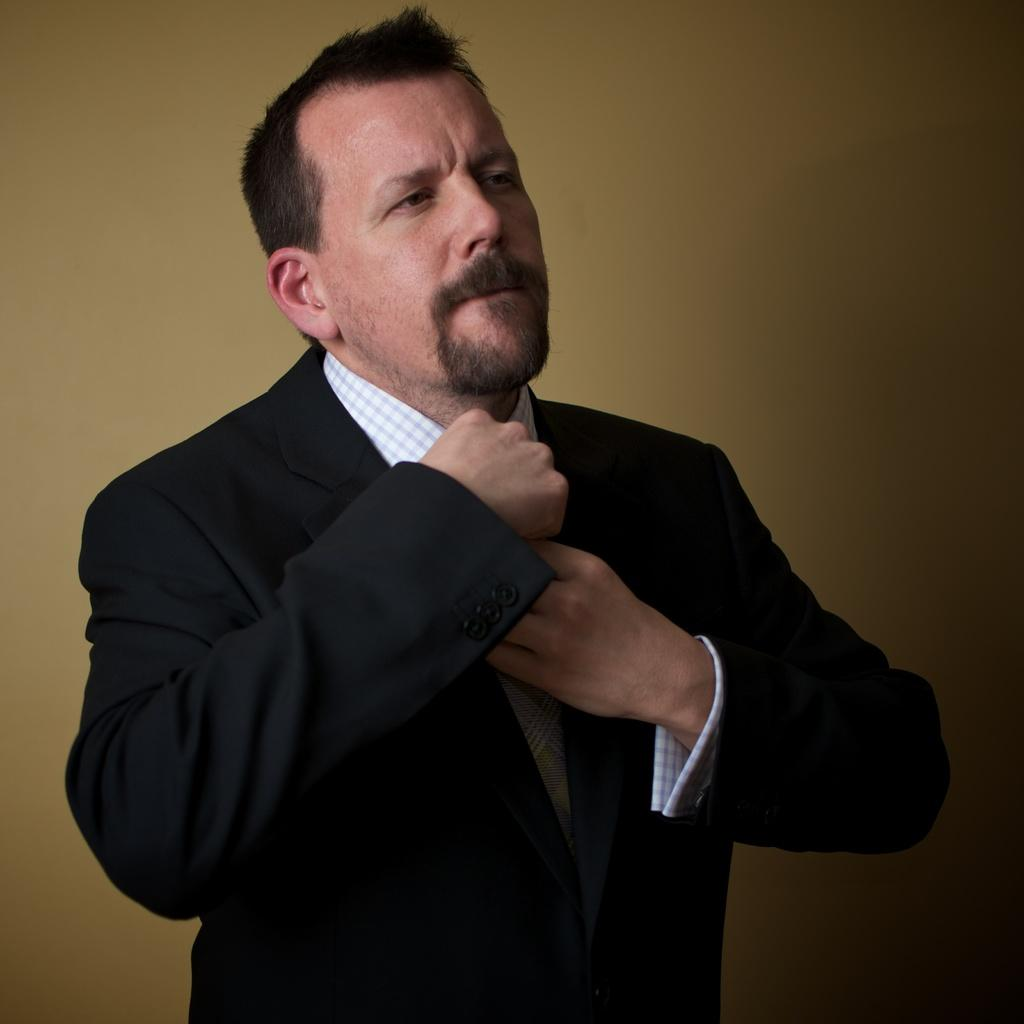Who or what is present in the image? There is a person in the image. What type of clothing is the person wearing? The person is wearing a blazer. What can be seen in the background of the image? There is a wall in the background of the image. Can you hear the whistle of the game in the image? There is no whistle or game present in the image; it only features a person wearing a blazer with a wall in the background. 